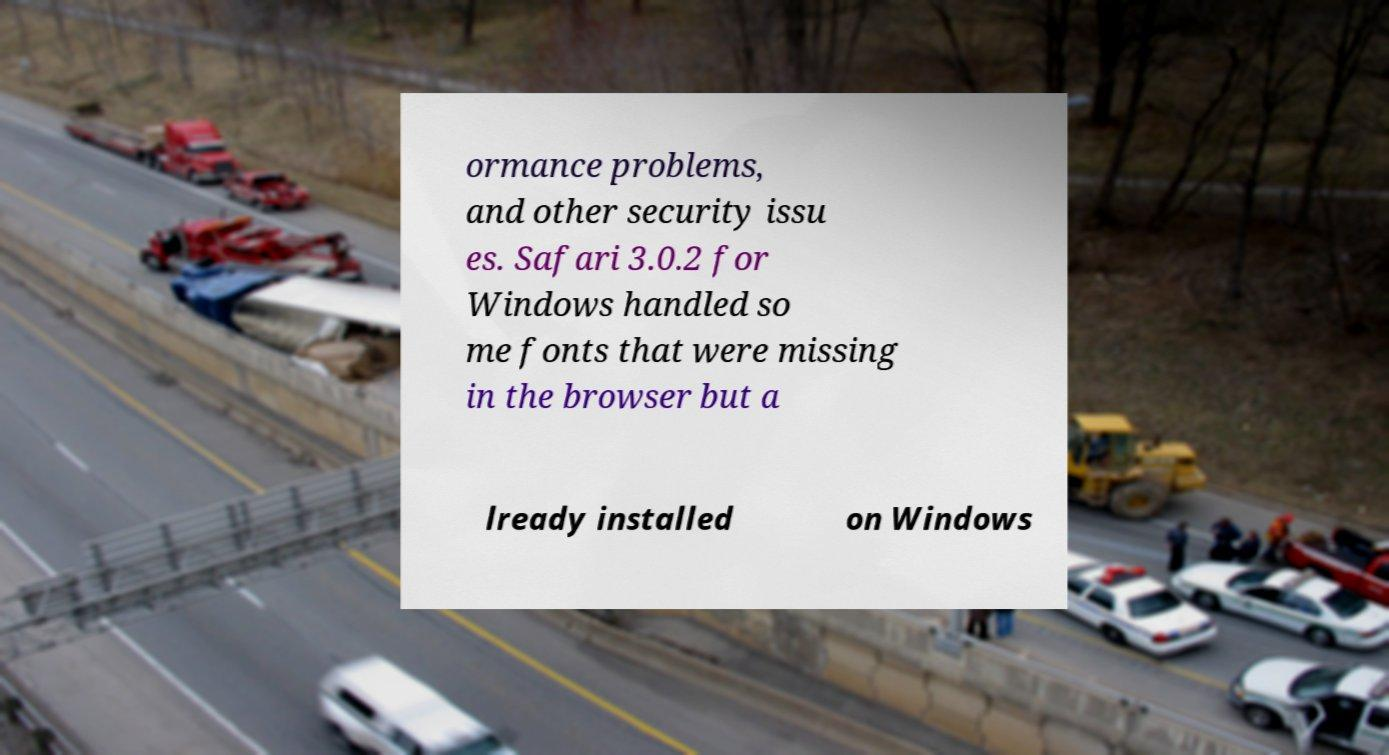I need the written content from this picture converted into text. Can you do that? ormance problems, and other security issu es. Safari 3.0.2 for Windows handled so me fonts that were missing in the browser but a lready installed on Windows 